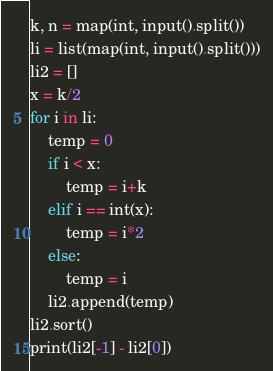<code> <loc_0><loc_0><loc_500><loc_500><_Python_>k, n = map(int, input().split())
li = list(map(int, input().split()))
li2 = []
x = k/2
for i in li:
    temp = 0
    if i < x:
        temp = i+k
    elif i == int(x):
        temp = i*2
    else:
        temp = i
    li2.append(temp)
li2.sort()
print(li2[-1] - li2[0])</code> 